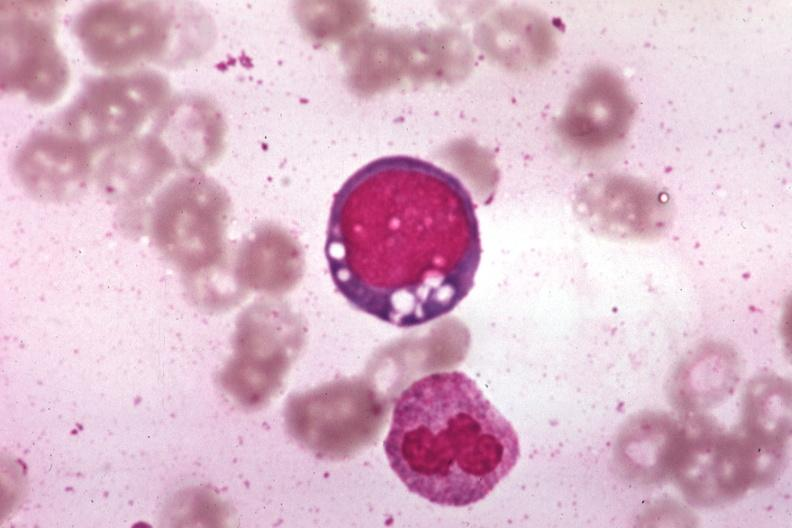what does this image show?
Answer the question using a single word or phrase. Wrights vacuolated erythroblast source unknown 